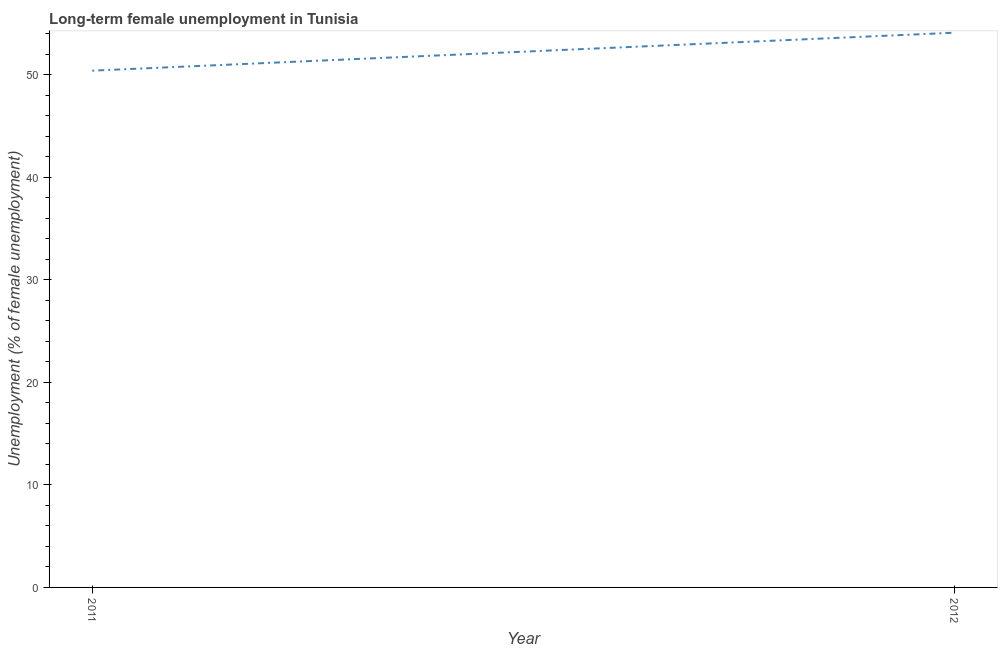What is the long-term female unemployment in 2012?
Your answer should be very brief. 54.1. Across all years, what is the maximum long-term female unemployment?
Make the answer very short. 54.1. Across all years, what is the minimum long-term female unemployment?
Provide a succinct answer. 50.4. In which year was the long-term female unemployment maximum?
Your answer should be very brief. 2012. What is the sum of the long-term female unemployment?
Your answer should be compact. 104.5. What is the difference between the long-term female unemployment in 2011 and 2012?
Keep it short and to the point. -3.7. What is the average long-term female unemployment per year?
Offer a terse response. 52.25. What is the median long-term female unemployment?
Make the answer very short. 52.25. Do a majority of the years between 2011 and 2012 (inclusive) have long-term female unemployment greater than 52 %?
Your answer should be very brief. No. What is the ratio of the long-term female unemployment in 2011 to that in 2012?
Give a very brief answer. 0.93. Is the long-term female unemployment in 2011 less than that in 2012?
Your response must be concise. Yes. In how many years, is the long-term female unemployment greater than the average long-term female unemployment taken over all years?
Your answer should be very brief. 1. Does the long-term female unemployment monotonically increase over the years?
Provide a short and direct response. Yes. How many years are there in the graph?
Offer a terse response. 2. Are the values on the major ticks of Y-axis written in scientific E-notation?
Give a very brief answer. No. Does the graph contain any zero values?
Provide a succinct answer. No. Does the graph contain grids?
Your answer should be compact. No. What is the title of the graph?
Offer a very short reply. Long-term female unemployment in Tunisia. What is the label or title of the X-axis?
Provide a succinct answer. Year. What is the label or title of the Y-axis?
Offer a terse response. Unemployment (% of female unemployment). What is the Unemployment (% of female unemployment) of 2011?
Offer a terse response. 50.4. What is the Unemployment (% of female unemployment) of 2012?
Your answer should be very brief. 54.1. What is the difference between the Unemployment (% of female unemployment) in 2011 and 2012?
Make the answer very short. -3.7. What is the ratio of the Unemployment (% of female unemployment) in 2011 to that in 2012?
Your answer should be very brief. 0.93. 